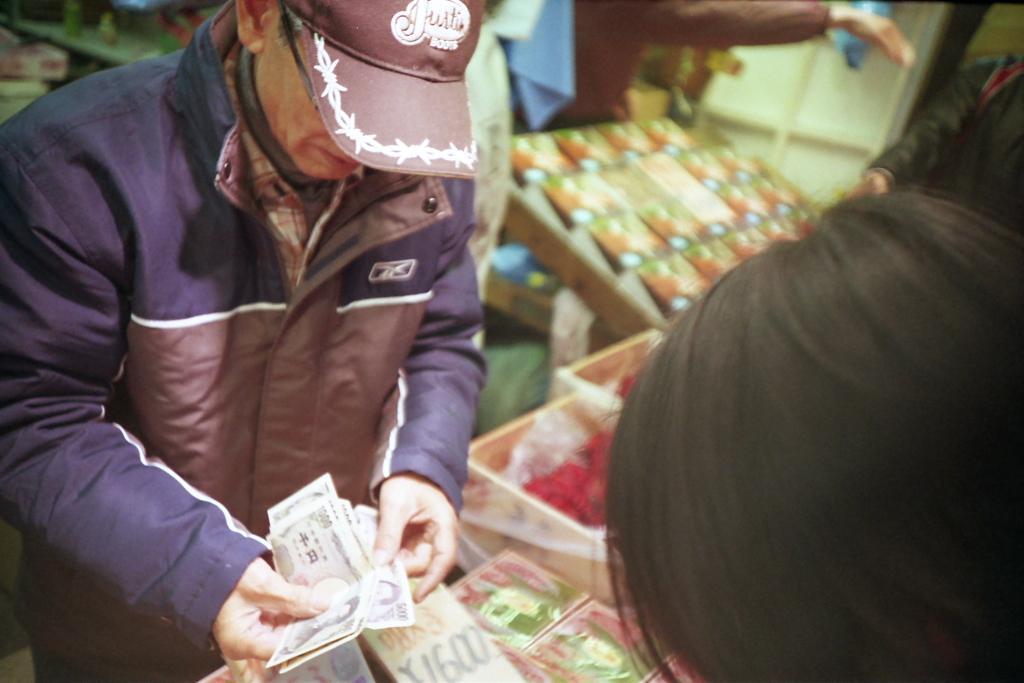Could you give a brief overview of what you see in this image? A person wore jacket, cap and holding currency. Background it is blur. Here we can see people and things. 